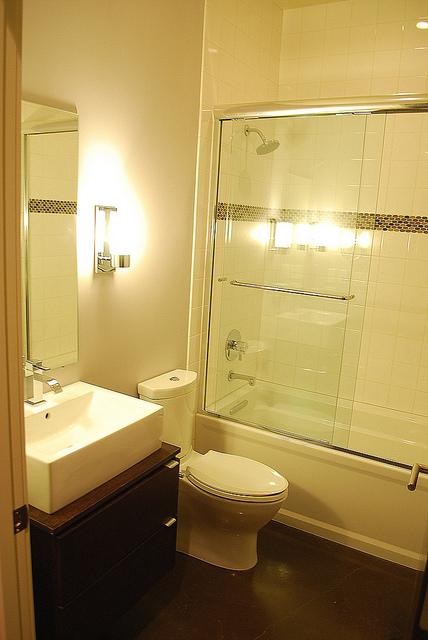Is the toilet seat down?
Quick response, please. Yes. Where would a person hand their towels?
Write a very short answer. Rack. Is there tile on the wall?
Give a very brief answer. No. Is the lid on the toilet up or down?
Concise answer only. Down. What color is the shower curtain?
Concise answer only. Clear. What is the sink made of?
Quick response, please. Porcelain. Is the toilet seat up?
Concise answer only. No. Is the shower on?
Be succinct. No. 